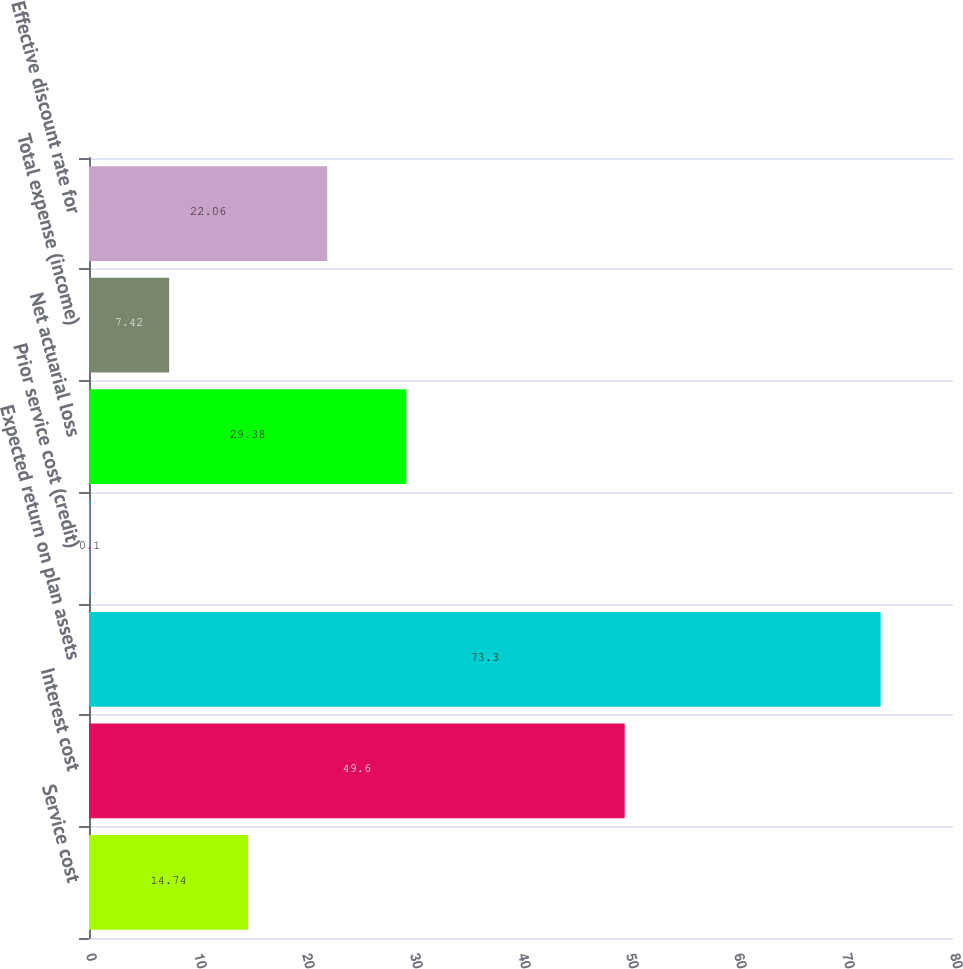Convert chart to OTSL. <chart><loc_0><loc_0><loc_500><loc_500><bar_chart><fcel>Service cost<fcel>Interest cost<fcel>Expected return on plan assets<fcel>Prior service cost (credit)<fcel>Net actuarial loss<fcel>Total expense (income)<fcel>Effective discount rate for<nl><fcel>14.74<fcel>49.6<fcel>73.3<fcel>0.1<fcel>29.38<fcel>7.42<fcel>22.06<nl></chart> 